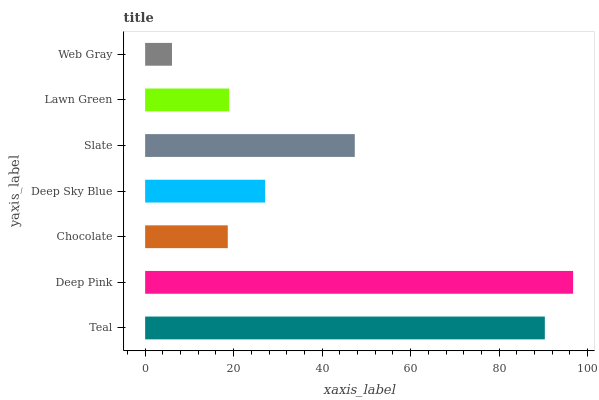Is Web Gray the minimum?
Answer yes or no. Yes. Is Deep Pink the maximum?
Answer yes or no. Yes. Is Chocolate the minimum?
Answer yes or no. No. Is Chocolate the maximum?
Answer yes or no. No. Is Deep Pink greater than Chocolate?
Answer yes or no. Yes. Is Chocolate less than Deep Pink?
Answer yes or no. Yes. Is Chocolate greater than Deep Pink?
Answer yes or no. No. Is Deep Pink less than Chocolate?
Answer yes or no. No. Is Deep Sky Blue the high median?
Answer yes or no. Yes. Is Deep Sky Blue the low median?
Answer yes or no. Yes. Is Lawn Green the high median?
Answer yes or no. No. Is Web Gray the low median?
Answer yes or no. No. 